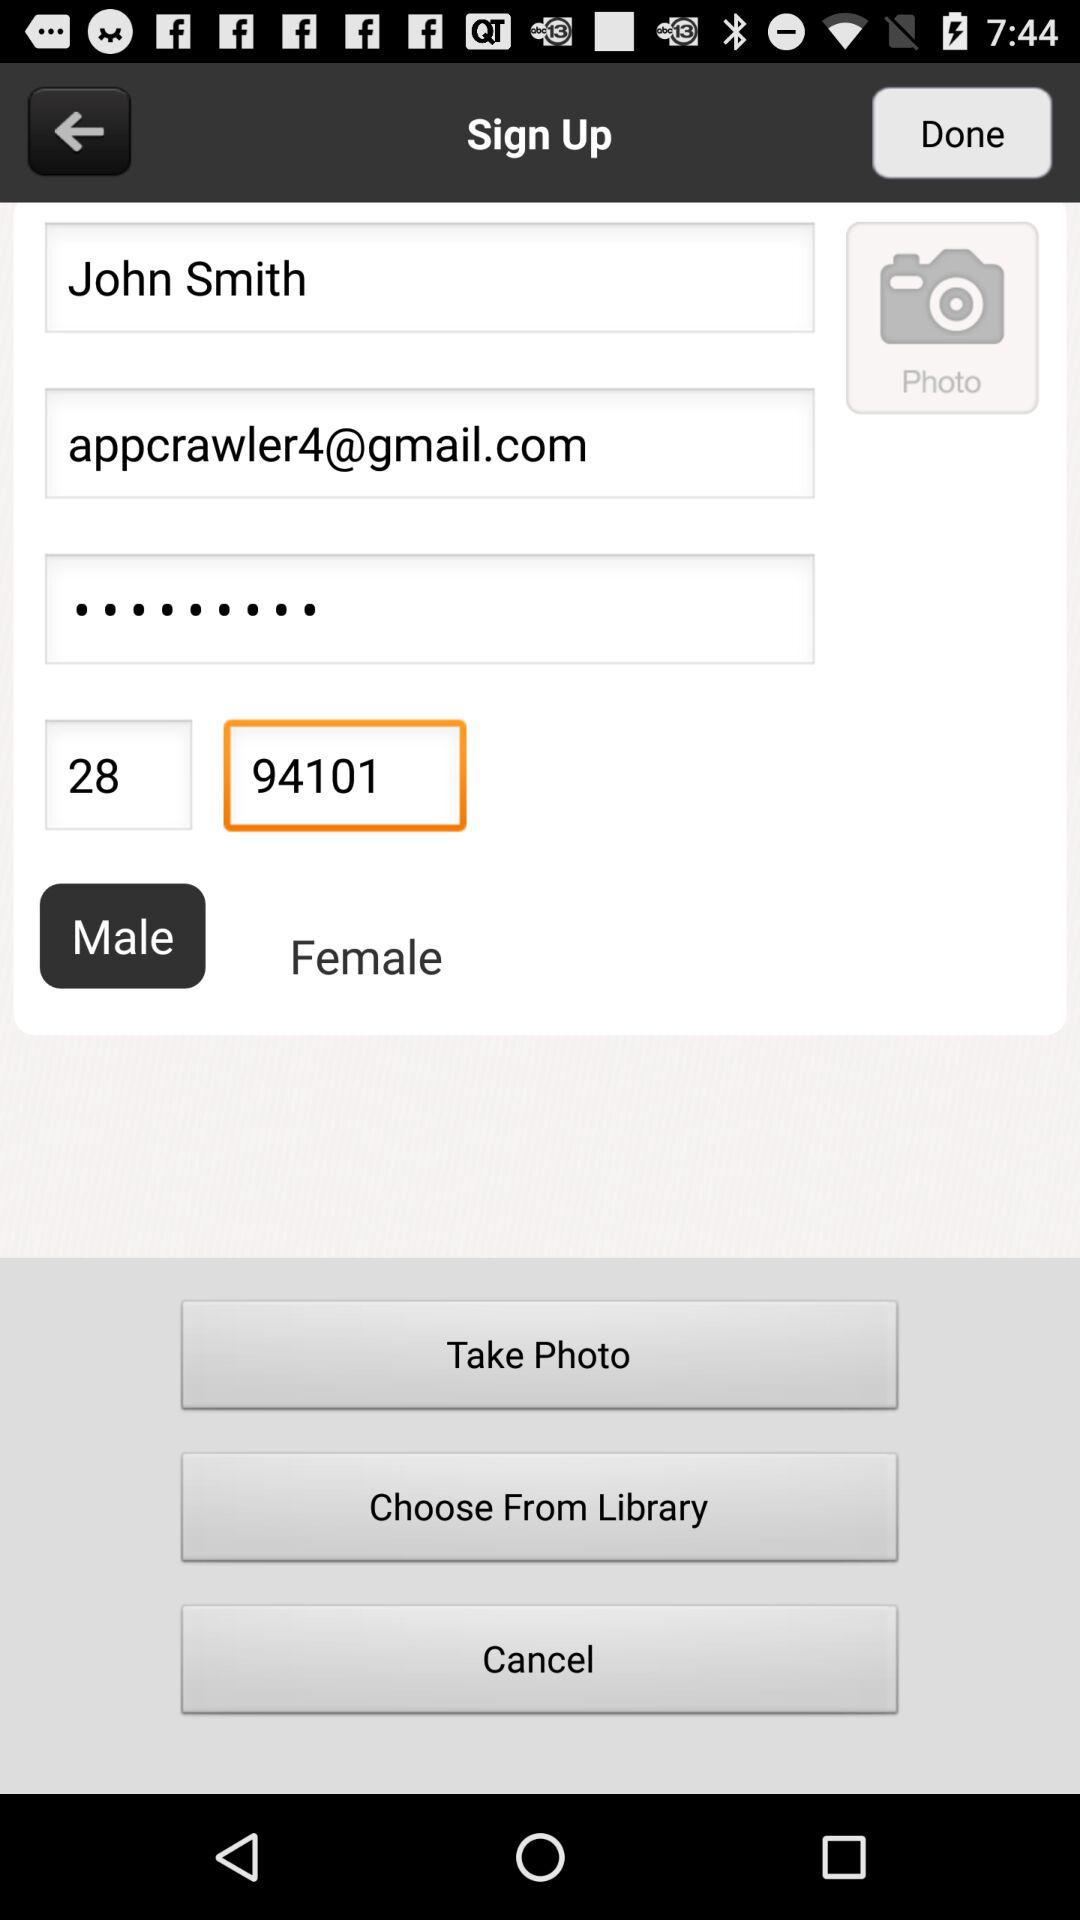What is the phone number?
When the provided information is insufficient, respond with <no answer>. <no answer> 